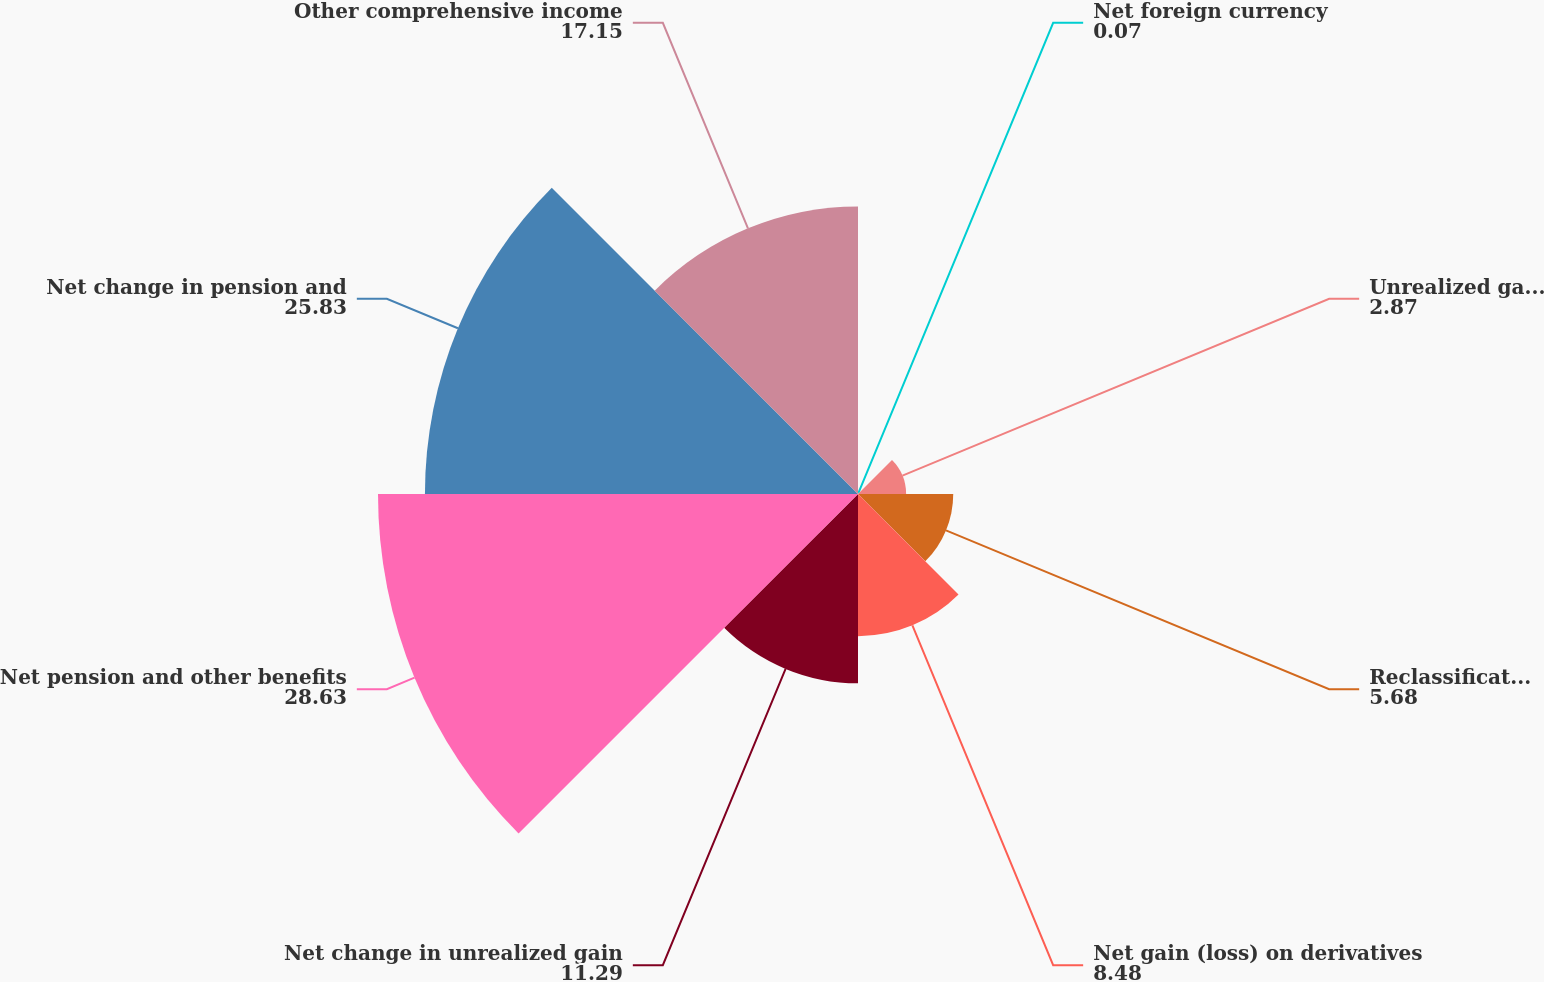Convert chart to OTSL. <chart><loc_0><loc_0><loc_500><loc_500><pie_chart><fcel>Net foreign currency<fcel>Unrealized gains (losses)<fcel>Reclassification adjustments<fcel>Net gain (loss) on derivatives<fcel>Net change in unrealized gain<fcel>Net pension and other benefits<fcel>Net change in pension and<fcel>Other comprehensive income<nl><fcel>0.07%<fcel>2.87%<fcel>5.68%<fcel>8.48%<fcel>11.29%<fcel>28.63%<fcel>25.83%<fcel>17.15%<nl></chart> 